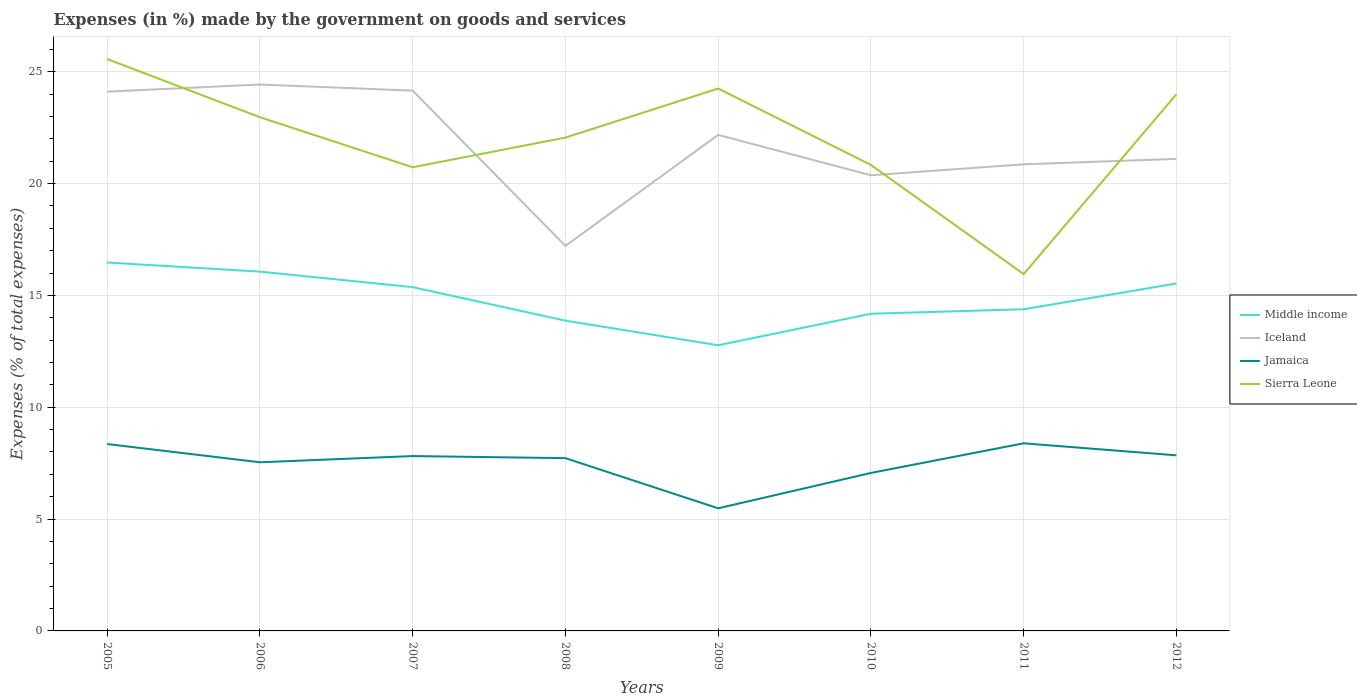How many different coloured lines are there?
Offer a very short reply. 4. Across all years, what is the maximum percentage of expenses made by the government on goods and services in Sierra Leone?
Keep it short and to the point. 15.95. In which year was the percentage of expenses made by the government on goods and services in Sierra Leone maximum?
Provide a succinct answer. 2011. What is the total percentage of expenses made by the government on goods and services in Jamaica in the graph?
Provide a succinct answer. -0.18. What is the difference between the highest and the second highest percentage of expenses made by the government on goods and services in Middle income?
Keep it short and to the point. 3.7. Is the percentage of expenses made by the government on goods and services in Jamaica strictly greater than the percentage of expenses made by the government on goods and services in Sierra Leone over the years?
Your answer should be compact. Yes. Are the values on the major ticks of Y-axis written in scientific E-notation?
Offer a terse response. No. Does the graph contain any zero values?
Offer a very short reply. No. Does the graph contain grids?
Provide a succinct answer. Yes. Where does the legend appear in the graph?
Offer a very short reply. Center right. How are the legend labels stacked?
Your response must be concise. Vertical. What is the title of the graph?
Your response must be concise. Expenses (in %) made by the government on goods and services. What is the label or title of the X-axis?
Provide a short and direct response. Years. What is the label or title of the Y-axis?
Give a very brief answer. Expenses (% of total expenses). What is the Expenses (% of total expenses) of Middle income in 2005?
Offer a terse response. 16.47. What is the Expenses (% of total expenses) in Iceland in 2005?
Offer a very short reply. 24.11. What is the Expenses (% of total expenses) of Jamaica in 2005?
Provide a succinct answer. 8.36. What is the Expenses (% of total expenses) of Sierra Leone in 2005?
Keep it short and to the point. 25.57. What is the Expenses (% of total expenses) in Middle income in 2006?
Your response must be concise. 16.07. What is the Expenses (% of total expenses) in Iceland in 2006?
Offer a terse response. 24.43. What is the Expenses (% of total expenses) in Jamaica in 2006?
Provide a short and direct response. 7.54. What is the Expenses (% of total expenses) in Sierra Leone in 2006?
Offer a very short reply. 22.97. What is the Expenses (% of total expenses) in Middle income in 2007?
Your answer should be compact. 15.37. What is the Expenses (% of total expenses) in Iceland in 2007?
Offer a terse response. 24.16. What is the Expenses (% of total expenses) in Jamaica in 2007?
Make the answer very short. 7.82. What is the Expenses (% of total expenses) in Sierra Leone in 2007?
Keep it short and to the point. 20.73. What is the Expenses (% of total expenses) of Middle income in 2008?
Give a very brief answer. 13.87. What is the Expenses (% of total expenses) of Iceland in 2008?
Your answer should be very brief. 17.22. What is the Expenses (% of total expenses) of Jamaica in 2008?
Your response must be concise. 7.72. What is the Expenses (% of total expenses) in Sierra Leone in 2008?
Keep it short and to the point. 22.06. What is the Expenses (% of total expenses) in Middle income in 2009?
Provide a succinct answer. 12.77. What is the Expenses (% of total expenses) of Iceland in 2009?
Make the answer very short. 22.18. What is the Expenses (% of total expenses) in Jamaica in 2009?
Provide a short and direct response. 5.48. What is the Expenses (% of total expenses) in Sierra Leone in 2009?
Provide a short and direct response. 24.25. What is the Expenses (% of total expenses) of Middle income in 2010?
Offer a very short reply. 14.18. What is the Expenses (% of total expenses) of Iceland in 2010?
Keep it short and to the point. 20.37. What is the Expenses (% of total expenses) in Jamaica in 2010?
Offer a terse response. 7.06. What is the Expenses (% of total expenses) in Sierra Leone in 2010?
Provide a succinct answer. 20.84. What is the Expenses (% of total expenses) in Middle income in 2011?
Your answer should be very brief. 14.38. What is the Expenses (% of total expenses) of Iceland in 2011?
Your answer should be compact. 20.86. What is the Expenses (% of total expenses) of Jamaica in 2011?
Provide a short and direct response. 8.39. What is the Expenses (% of total expenses) in Sierra Leone in 2011?
Your response must be concise. 15.95. What is the Expenses (% of total expenses) of Middle income in 2012?
Your answer should be compact. 15.53. What is the Expenses (% of total expenses) of Iceland in 2012?
Make the answer very short. 21.11. What is the Expenses (% of total expenses) in Jamaica in 2012?
Provide a succinct answer. 7.85. What is the Expenses (% of total expenses) of Sierra Leone in 2012?
Give a very brief answer. 24. Across all years, what is the maximum Expenses (% of total expenses) in Middle income?
Your answer should be very brief. 16.47. Across all years, what is the maximum Expenses (% of total expenses) in Iceland?
Offer a very short reply. 24.43. Across all years, what is the maximum Expenses (% of total expenses) in Jamaica?
Ensure brevity in your answer.  8.39. Across all years, what is the maximum Expenses (% of total expenses) in Sierra Leone?
Ensure brevity in your answer.  25.57. Across all years, what is the minimum Expenses (% of total expenses) in Middle income?
Your response must be concise. 12.77. Across all years, what is the minimum Expenses (% of total expenses) of Iceland?
Offer a very short reply. 17.22. Across all years, what is the minimum Expenses (% of total expenses) in Jamaica?
Ensure brevity in your answer.  5.48. Across all years, what is the minimum Expenses (% of total expenses) in Sierra Leone?
Your answer should be compact. 15.95. What is the total Expenses (% of total expenses) in Middle income in the graph?
Keep it short and to the point. 118.65. What is the total Expenses (% of total expenses) in Iceland in the graph?
Your answer should be very brief. 174.44. What is the total Expenses (% of total expenses) in Jamaica in the graph?
Keep it short and to the point. 60.22. What is the total Expenses (% of total expenses) in Sierra Leone in the graph?
Make the answer very short. 176.37. What is the difference between the Expenses (% of total expenses) of Middle income in 2005 and that in 2006?
Offer a very short reply. 0.41. What is the difference between the Expenses (% of total expenses) in Iceland in 2005 and that in 2006?
Give a very brief answer. -0.32. What is the difference between the Expenses (% of total expenses) in Jamaica in 2005 and that in 2006?
Provide a succinct answer. 0.82. What is the difference between the Expenses (% of total expenses) of Sierra Leone in 2005 and that in 2006?
Your answer should be very brief. 2.6. What is the difference between the Expenses (% of total expenses) in Middle income in 2005 and that in 2007?
Provide a succinct answer. 1.1. What is the difference between the Expenses (% of total expenses) in Iceland in 2005 and that in 2007?
Your answer should be compact. -0.04. What is the difference between the Expenses (% of total expenses) of Jamaica in 2005 and that in 2007?
Make the answer very short. 0.54. What is the difference between the Expenses (% of total expenses) in Sierra Leone in 2005 and that in 2007?
Give a very brief answer. 4.84. What is the difference between the Expenses (% of total expenses) in Middle income in 2005 and that in 2008?
Make the answer very short. 2.6. What is the difference between the Expenses (% of total expenses) in Iceland in 2005 and that in 2008?
Your answer should be compact. 6.9. What is the difference between the Expenses (% of total expenses) in Jamaica in 2005 and that in 2008?
Make the answer very short. 0.63. What is the difference between the Expenses (% of total expenses) of Sierra Leone in 2005 and that in 2008?
Ensure brevity in your answer.  3.51. What is the difference between the Expenses (% of total expenses) of Middle income in 2005 and that in 2009?
Provide a short and direct response. 3.7. What is the difference between the Expenses (% of total expenses) in Iceland in 2005 and that in 2009?
Your answer should be compact. 1.93. What is the difference between the Expenses (% of total expenses) of Jamaica in 2005 and that in 2009?
Offer a very short reply. 2.87. What is the difference between the Expenses (% of total expenses) of Sierra Leone in 2005 and that in 2009?
Offer a terse response. 1.32. What is the difference between the Expenses (% of total expenses) in Middle income in 2005 and that in 2010?
Offer a very short reply. 2.29. What is the difference between the Expenses (% of total expenses) in Iceland in 2005 and that in 2010?
Provide a short and direct response. 3.74. What is the difference between the Expenses (% of total expenses) of Jamaica in 2005 and that in 2010?
Make the answer very short. 1.29. What is the difference between the Expenses (% of total expenses) of Sierra Leone in 2005 and that in 2010?
Keep it short and to the point. 4.73. What is the difference between the Expenses (% of total expenses) of Middle income in 2005 and that in 2011?
Give a very brief answer. 2.09. What is the difference between the Expenses (% of total expenses) in Iceland in 2005 and that in 2011?
Provide a succinct answer. 3.25. What is the difference between the Expenses (% of total expenses) of Jamaica in 2005 and that in 2011?
Provide a succinct answer. -0.03. What is the difference between the Expenses (% of total expenses) of Sierra Leone in 2005 and that in 2011?
Your response must be concise. 9.62. What is the difference between the Expenses (% of total expenses) in Middle income in 2005 and that in 2012?
Give a very brief answer. 0.94. What is the difference between the Expenses (% of total expenses) of Iceland in 2005 and that in 2012?
Ensure brevity in your answer.  3.01. What is the difference between the Expenses (% of total expenses) of Jamaica in 2005 and that in 2012?
Offer a very short reply. 0.51. What is the difference between the Expenses (% of total expenses) in Sierra Leone in 2005 and that in 2012?
Offer a terse response. 1.57. What is the difference between the Expenses (% of total expenses) of Middle income in 2006 and that in 2007?
Your answer should be compact. 0.69. What is the difference between the Expenses (% of total expenses) of Iceland in 2006 and that in 2007?
Make the answer very short. 0.27. What is the difference between the Expenses (% of total expenses) of Jamaica in 2006 and that in 2007?
Your answer should be compact. -0.28. What is the difference between the Expenses (% of total expenses) in Sierra Leone in 2006 and that in 2007?
Provide a short and direct response. 2.24. What is the difference between the Expenses (% of total expenses) of Middle income in 2006 and that in 2008?
Give a very brief answer. 2.19. What is the difference between the Expenses (% of total expenses) of Iceland in 2006 and that in 2008?
Offer a very short reply. 7.22. What is the difference between the Expenses (% of total expenses) of Jamaica in 2006 and that in 2008?
Make the answer very short. -0.18. What is the difference between the Expenses (% of total expenses) in Sierra Leone in 2006 and that in 2008?
Your answer should be very brief. 0.91. What is the difference between the Expenses (% of total expenses) in Middle income in 2006 and that in 2009?
Ensure brevity in your answer.  3.29. What is the difference between the Expenses (% of total expenses) of Iceland in 2006 and that in 2009?
Offer a terse response. 2.25. What is the difference between the Expenses (% of total expenses) in Jamaica in 2006 and that in 2009?
Keep it short and to the point. 2.06. What is the difference between the Expenses (% of total expenses) in Sierra Leone in 2006 and that in 2009?
Ensure brevity in your answer.  -1.28. What is the difference between the Expenses (% of total expenses) in Middle income in 2006 and that in 2010?
Your answer should be compact. 1.88. What is the difference between the Expenses (% of total expenses) of Iceland in 2006 and that in 2010?
Ensure brevity in your answer.  4.06. What is the difference between the Expenses (% of total expenses) of Jamaica in 2006 and that in 2010?
Give a very brief answer. 0.48. What is the difference between the Expenses (% of total expenses) of Sierra Leone in 2006 and that in 2010?
Ensure brevity in your answer.  2.13. What is the difference between the Expenses (% of total expenses) of Middle income in 2006 and that in 2011?
Ensure brevity in your answer.  1.68. What is the difference between the Expenses (% of total expenses) of Iceland in 2006 and that in 2011?
Your answer should be very brief. 3.57. What is the difference between the Expenses (% of total expenses) in Jamaica in 2006 and that in 2011?
Offer a very short reply. -0.85. What is the difference between the Expenses (% of total expenses) of Sierra Leone in 2006 and that in 2011?
Give a very brief answer. 7.01. What is the difference between the Expenses (% of total expenses) in Middle income in 2006 and that in 2012?
Make the answer very short. 0.53. What is the difference between the Expenses (% of total expenses) of Iceland in 2006 and that in 2012?
Offer a terse response. 3.33. What is the difference between the Expenses (% of total expenses) of Jamaica in 2006 and that in 2012?
Give a very brief answer. -0.31. What is the difference between the Expenses (% of total expenses) of Sierra Leone in 2006 and that in 2012?
Your answer should be compact. -1.03. What is the difference between the Expenses (% of total expenses) in Middle income in 2007 and that in 2008?
Give a very brief answer. 1.5. What is the difference between the Expenses (% of total expenses) of Iceland in 2007 and that in 2008?
Ensure brevity in your answer.  6.94. What is the difference between the Expenses (% of total expenses) in Jamaica in 2007 and that in 2008?
Offer a very short reply. 0.09. What is the difference between the Expenses (% of total expenses) in Sierra Leone in 2007 and that in 2008?
Your answer should be very brief. -1.33. What is the difference between the Expenses (% of total expenses) of Middle income in 2007 and that in 2009?
Make the answer very short. 2.6. What is the difference between the Expenses (% of total expenses) in Iceland in 2007 and that in 2009?
Offer a terse response. 1.98. What is the difference between the Expenses (% of total expenses) in Jamaica in 2007 and that in 2009?
Provide a succinct answer. 2.34. What is the difference between the Expenses (% of total expenses) in Sierra Leone in 2007 and that in 2009?
Your answer should be compact. -3.52. What is the difference between the Expenses (% of total expenses) in Middle income in 2007 and that in 2010?
Your answer should be compact. 1.19. What is the difference between the Expenses (% of total expenses) of Iceland in 2007 and that in 2010?
Your response must be concise. 3.78. What is the difference between the Expenses (% of total expenses) of Jamaica in 2007 and that in 2010?
Offer a terse response. 0.75. What is the difference between the Expenses (% of total expenses) of Sierra Leone in 2007 and that in 2010?
Provide a succinct answer. -0.1. What is the difference between the Expenses (% of total expenses) in Middle income in 2007 and that in 2011?
Ensure brevity in your answer.  0.99. What is the difference between the Expenses (% of total expenses) of Iceland in 2007 and that in 2011?
Provide a short and direct response. 3.29. What is the difference between the Expenses (% of total expenses) in Jamaica in 2007 and that in 2011?
Ensure brevity in your answer.  -0.57. What is the difference between the Expenses (% of total expenses) in Sierra Leone in 2007 and that in 2011?
Provide a short and direct response. 4.78. What is the difference between the Expenses (% of total expenses) in Middle income in 2007 and that in 2012?
Provide a short and direct response. -0.16. What is the difference between the Expenses (% of total expenses) of Iceland in 2007 and that in 2012?
Offer a terse response. 3.05. What is the difference between the Expenses (% of total expenses) in Jamaica in 2007 and that in 2012?
Make the answer very short. -0.03. What is the difference between the Expenses (% of total expenses) in Sierra Leone in 2007 and that in 2012?
Keep it short and to the point. -3.27. What is the difference between the Expenses (% of total expenses) of Middle income in 2008 and that in 2009?
Your answer should be very brief. 1.1. What is the difference between the Expenses (% of total expenses) of Iceland in 2008 and that in 2009?
Keep it short and to the point. -4.96. What is the difference between the Expenses (% of total expenses) in Jamaica in 2008 and that in 2009?
Ensure brevity in your answer.  2.24. What is the difference between the Expenses (% of total expenses) of Sierra Leone in 2008 and that in 2009?
Make the answer very short. -2.19. What is the difference between the Expenses (% of total expenses) of Middle income in 2008 and that in 2010?
Make the answer very short. -0.31. What is the difference between the Expenses (% of total expenses) of Iceland in 2008 and that in 2010?
Provide a short and direct response. -3.16. What is the difference between the Expenses (% of total expenses) of Jamaica in 2008 and that in 2010?
Your answer should be compact. 0.66. What is the difference between the Expenses (% of total expenses) of Sierra Leone in 2008 and that in 2010?
Offer a very short reply. 1.22. What is the difference between the Expenses (% of total expenses) of Middle income in 2008 and that in 2011?
Your response must be concise. -0.51. What is the difference between the Expenses (% of total expenses) of Iceland in 2008 and that in 2011?
Ensure brevity in your answer.  -3.65. What is the difference between the Expenses (% of total expenses) of Jamaica in 2008 and that in 2011?
Keep it short and to the point. -0.66. What is the difference between the Expenses (% of total expenses) of Sierra Leone in 2008 and that in 2011?
Provide a short and direct response. 6.1. What is the difference between the Expenses (% of total expenses) in Middle income in 2008 and that in 2012?
Your answer should be compact. -1.66. What is the difference between the Expenses (% of total expenses) of Iceland in 2008 and that in 2012?
Your answer should be compact. -3.89. What is the difference between the Expenses (% of total expenses) of Jamaica in 2008 and that in 2012?
Your answer should be compact. -0.13. What is the difference between the Expenses (% of total expenses) in Sierra Leone in 2008 and that in 2012?
Ensure brevity in your answer.  -1.94. What is the difference between the Expenses (% of total expenses) of Middle income in 2009 and that in 2010?
Keep it short and to the point. -1.41. What is the difference between the Expenses (% of total expenses) of Iceland in 2009 and that in 2010?
Provide a short and direct response. 1.8. What is the difference between the Expenses (% of total expenses) of Jamaica in 2009 and that in 2010?
Your answer should be very brief. -1.58. What is the difference between the Expenses (% of total expenses) of Sierra Leone in 2009 and that in 2010?
Keep it short and to the point. 3.42. What is the difference between the Expenses (% of total expenses) in Middle income in 2009 and that in 2011?
Your answer should be very brief. -1.61. What is the difference between the Expenses (% of total expenses) in Iceland in 2009 and that in 2011?
Ensure brevity in your answer.  1.32. What is the difference between the Expenses (% of total expenses) of Jamaica in 2009 and that in 2011?
Make the answer very short. -2.91. What is the difference between the Expenses (% of total expenses) in Sierra Leone in 2009 and that in 2011?
Offer a very short reply. 8.3. What is the difference between the Expenses (% of total expenses) in Middle income in 2009 and that in 2012?
Give a very brief answer. -2.76. What is the difference between the Expenses (% of total expenses) of Iceland in 2009 and that in 2012?
Make the answer very short. 1.07. What is the difference between the Expenses (% of total expenses) of Jamaica in 2009 and that in 2012?
Provide a short and direct response. -2.37. What is the difference between the Expenses (% of total expenses) in Sierra Leone in 2009 and that in 2012?
Offer a terse response. 0.25. What is the difference between the Expenses (% of total expenses) of Middle income in 2010 and that in 2011?
Your answer should be compact. -0.2. What is the difference between the Expenses (% of total expenses) in Iceland in 2010 and that in 2011?
Make the answer very short. -0.49. What is the difference between the Expenses (% of total expenses) of Jamaica in 2010 and that in 2011?
Offer a terse response. -1.32. What is the difference between the Expenses (% of total expenses) of Sierra Leone in 2010 and that in 2011?
Ensure brevity in your answer.  4.88. What is the difference between the Expenses (% of total expenses) of Middle income in 2010 and that in 2012?
Your answer should be very brief. -1.35. What is the difference between the Expenses (% of total expenses) of Iceland in 2010 and that in 2012?
Give a very brief answer. -0.73. What is the difference between the Expenses (% of total expenses) of Jamaica in 2010 and that in 2012?
Your answer should be compact. -0.79. What is the difference between the Expenses (% of total expenses) of Sierra Leone in 2010 and that in 2012?
Make the answer very short. -3.16. What is the difference between the Expenses (% of total expenses) of Middle income in 2011 and that in 2012?
Offer a terse response. -1.15. What is the difference between the Expenses (% of total expenses) in Iceland in 2011 and that in 2012?
Your response must be concise. -0.24. What is the difference between the Expenses (% of total expenses) of Jamaica in 2011 and that in 2012?
Your response must be concise. 0.54. What is the difference between the Expenses (% of total expenses) of Sierra Leone in 2011 and that in 2012?
Ensure brevity in your answer.  -8.04. What is the difference between the Expenses (% of total expenses) in Middle income in 2005 and the Expenses (% of total expenses) in Iceland in 2006?
Ensure brevity in your answer.  -7.96. What is the difference between the Expenses (% of total expenses) in Middle income in 2005 and the Expenses (% of total expenses) in Jamaica in 2006?
Ensure brevity in your answer.  8.93. What is the difference between the Expenses (% of total expenses) in Middle income in 2005 and the Expenses (% of total expenses) in Sierra Leone in 2006?
Make the answer very short. -6.5. What is the difference between the Expenses (% of total expenses) in Iceland in 2005 and the Expenses (% of total expenses) in Jamaica in 2006?
Offer a terse response. 16.57. What is the difference between the Expenses (% of total expenses) in Iceland in 2005 and the Expenses (% of total expenses) in Sierra Leone in 2006?
Offer a terse response. 1.14. What is the difference between the Expenses (% of total expenses) in Jamaica in 2005 and the Expenses (% of total expenses) in Sierra Leone in 2006?
Your answer should be compact. -14.61. What is the difference between the Expenses (% of total expenses) of Middle income in 2005 and the Expenses (% of total expenses) of Iceland in 2007?
Keep it short and to the point. -7.68. What is the difference between the Expenses (% of total expenses) of Middle income in 2005 and the Expenses (% of total expenses) of Jamaica in 2007?
Your answer should be very brief. 8.65. What is the difference between the Expenses (% of total expenses) of Middle income in 2005 and the Expenses (% of total expenses) of Sierra Leone in 2007?
Keep it short and to the point. -4.26. What is the difference between the Expenses (% of total expenses) in Iceland in 2005 and the Expenses (% of total expenses) in Jamaica in 2007?
Your response must be concise. 16.29. What is the difference between the Expenses (% of total expenses) of Iceland in 2005 and the Expenses (% of total expenses) of Sierra Leone in 2007?
Your answer should be very brief. 3.38. What is the difference between the Expenses (% of total expenses) in Jamaica in 2005 and the Expenses (% of total expenses) in Sierra Leone in 2007?
Offer a very short reply. -12.38. What is the difference between the Expenses (% of total expenses) of Middle income in 2005 and the Expenses (% of total expenses) of Iceland in 2008?
Ensure brevity in your answer.  -0.74. What is the difference between the Expenses (% of total expenses) in Middle income in 2005 and the Expenses (% of total expenses) in Jamaica in 2008?
Your response must be concise. 8.75. What is the difference between the Expenses (% of total expenses) of Middle income in 2005 and the Expenses (% of total expenses) of Sierra Leone in 2008?
Provide a short and direct response. -5.58. What is the difference between the Expenses (% of total expenses) in Iceland in 2005 and the Expenses (% of total expenses) in Jamaica in 2008?
Offer a terse response. 16.39. What is the difference between the Expenses (% of total expenses) in Iceland in 2005 and the Expenses (% of total expenses) in Sierra Leone in 2008?
Provide a succinct answer. 2.05. What is the difference between the Expenses (% of total expenses) in Jamaica in 2005 and the Expenses (% of total expenses) in Sierra Leone in 2008?
Offer a terse response. -13.7. What is the difference between the Expenses (% of total expenses) in Middle income in 2005 and the Expenses (% of total expenses) in Iceland in 2009?
Offer a very short reply. -5.71. What is the difference between the Expenses (% of total expenses) in Middle income in 2005 and the Expenses (% of total expenses) in Jamaica in 2009?
Your answer should be very brief. 10.99. What is the difference between the Expenses (% of total expenses) in Middle income in 2005 and the Expenses (% of total expenses) in Sierra Leone in 2009?
Your answer should be compact. -7.78. What is the difference between the Expenses (% of total expenses) of Iceland in 2005 and the Expenses (% of total expenses) of Jamaica in 2009?
Offer a very short reply. 18.63. What is the difference between the Expenses (% of total expenses) of Iceland in 2005 and the Expenses (% of total expenses) of Sierra Leone in 2009?
Your answer should be compact. -0.14. What is the difference between the Expenses (% of total expenses) of Jamaica in 2005 and the Expenses (% of total expenses) of Sierra Leone in 2009?
Give a very brief answer. -15.9. What is the difference between the Expenses (% of total expenses) of Middle income in 2005 and the Expenses (% of total expenses) of Iceland in 2010?
Keep it short and to the point. -3.9. What is the difference between the Expenses (% of total expenses) in Middle income in 2005 and the Expenses (% of total expenses) in Jamaica in 2010?
Ensure brevity in your answer.  9.41. What is the difference between the Expenses (% of total expenses) of Middle income in 2005 and the Expenses (% of total expenses) of Sierra Leone in 2010?
Make the answer very short. -4.36. What is the difference between the Expenses (% of total expenses) of Iceland in 2005 and the Expenses (% of total expenses) of Jamaica in 2010?
Offer a very short reply. 17.05. What is the difference between the Expenses (% of total expenses) of Iceland in 2005 and the Expenses (% of total expenses) of Sierra Leone in 2010?
Your response must be concise. 3.28. What is the difference between the Expenses (% of total expenses) in Jamaica in 2005 and the Expenses (% of total expenses) in Sierra Leone in 2010?
Offer a terse response. -12.48. What is the difference between the Expenses (% of total expenses) of Middle income in 2005 and the Expenses (% of total expenses) of Iceland in 2011?
Ensure brevity in your answer.  -4.39. What is the difference between the Expenses (% of total expenses) in Middle income in 2005 and the Expenses (% of total expenses) in Jamaica in 2011?
Provide a succinct answer. 8.08. What is the difference between the Expenses (% of total expenses) of Middle income in 2005 and the Expenses (% of total expenses) of Sierra Leone in 2011?
Keep it short and to the point. 0.52. What is the difference between the Expenses (% of total expenses) in Iceland in 2005 and the Expenses (% of total expenses) in Jamaica in 2011?
Offer a very short reply. 15.72. What is the difference between the Expenses (% of total expenses) of Iceland in 2005 and the Expenses (% of total expenses) of Sierra Leone in 2011?
Provide a succinct answer. 8.16. What is the difference between the Expenses (% of total expenses) in Jamaica in 2005 and the Expenses (% of total expenses) in Sierra Leone in 2011?
Offer a very short reply. -7.6. What is the difference between the Expenses (% of total expenses) in Middle income in 2005 and the Expenses (% of total expenses) in Iceland in 2012?
Offer a terse response. -4.63. What is the difference between the Expenses (% of total expenses) of Middle income in 2005 and the Expenses (% of total expenses) of Jamaica in 2012?
Offer a very short reply. 8.62. What is the difference between the Expenses (% of total expenses) of Middle income in 2005 and the Expenses (% of total expenses) of Sierra Leone in 2012?
Give a very brief answer. -7.52. What is the difference between the Expenses (% of total expenses) in Iceland in 2005 and the Expenses (% of total expenses) in Jamaica in 2012?
Ensure brevity in your answer.  16.26. What is the difference between the Expenses (% of total expenses) of Iceland in 2005 and the Expenses (% of total expenses) of Sierra Leone in 2012?
Ensure brevity in your answer.  0.12. What is the difference between the Expenses (% of total expenses) in Jamaica in 2005 and the Expenses (% of total expenses) in Sierra Leone in 2012?
Provide a succinct answer. -15.64. What is the difference between the Expenses (% of total expenses) in Middle income in 2006 and the Expenses (% of total expenses) in Iceland in 2007?
Provide a short and direct response. -8.09. What is the difference between the Expenses (% of total expenses) of Middle income in 2006 and the Expenses (% of total expenses) of Jamaica in 2007?
Provide a short and direct response. 8.25. What is the difference between the Expenses (% of total expenses) of Middle income in 2006 and the Expenses (% of total expenses) of Sierra Leone in 2007?
Provide a succinct answer. -4.67. What is the difference between the Expenses (% of total expenses) in Iceland in 2006 and the Expenses (% of total expenses) in Jamaica in 2007?
Keep it short and to the point. 16.61. What is the difference between the Expenses (% of total expenses) of Iceland in 2006 and the Expenses (% of total expenses) of Sierra Leone in 2007?
Ensure brevity in your answer.  3.7. What is the difference between the Expenses (% of total expenses) of Jamaica in 2006 and the Expenses (% of total expenses) of Sierra Leone in 2007?
Keep it short and to the point. -13.19. What is the difference between the Expenses (% of total expenses) in Middle income in 2006 and the Expenses (% of total expenses) in Iceland in 2008?
Offer a terse response. -1.15. What is the difference between the Expenses (% of total expenses) of Middle income in 2006 and the Expenses (% of total expenses) of Jamaica in 2008?
Your response must be concise. 8.34. What is the difference between the Expenses (% of total expenses) in Middle income in 2006 and the Expenses (% of total expenses) in Sierra Leone in 2008?
Make the answer very short. -5.99. What is the difference between the Expenses (% of total expenses) in Iceland in 2006 and the Expenses (% of total expenses) in Jamaica in 2008?
Ensure brevity in your answer.  16.71. What is the difference between the Expenses (% of total expenses) of Iceland in 2006 and the Expenses (% of total expenses) of Sierra Leone in 2008?
Your response must be concise. 2.37. What is the difference between the Expenses (% of total expenses) of Jamaica in 2006 and the Expenses (% of total expenses) of Sierra Leone in 2008?
Your answer should be very brief. -14.52. What is the difference between the Expenses (% of total expenses) in Middle income in 2006 and the Expenses (% of total expenses) in Iceland in 2009?
Make the answer very short. -6.11. What is the difference between the Expenses (% of total expenses) of Middle income in 2006 and the Expenses (% of total expenses) of Jamaica in 2009?
Your answer should be compact. 10.58. What is the difference between the Expenses (% of total expenses) of Middle income in 2006 and the Expenses (% of total expenses) of Sierra Leone in 2009?
Your answer should be compact. -8.19. What is the difference between the Expenses (% of total expenses) of Iceland in 2006 and the Expenses (% of total expenses) of Jamaica in 2009?
Offer a terse response. 18.95. What is the difference between the Expenses (% of total expenses) in Iceland in 2006 and the Expenses (% of total expenses) in Sierra Leone in 2009?
Your response must be concise. 0.18. What is the difference between the Expenses (% of total expenses) of Jamaica in 2006 and the Expenses (% of total expenses) of Sierra Leone in 2009?
Offer a terse response. -16.71. What is the difference between the Expenses (% of total expenses) of Middle income in 2006 and the Expenses (% of total expenses) of Iceland in 2010?
Make the answer very short. -4.31. What is the difference between the Expenses (% of total expenses) in Middle income in 2006 and the Expenses (% of total expenses) in Jamaica in 2010?
Your response must be concise. 9. What is the difference between the Expenses (% of total expenses) in Middle income in 2006 and the Expenses (% of total expenses) in Sierra Leone in 2010?
Your response must be concise. -4.77. What is the difference between the Expenses (% of total expenses) of Iceland in 2006 and the Expenses (% of total expenses) of Jamaica in 2010?
Offer a terse response. 17.37. What is the difference between the Expenses (% of total expenses) of Iceland in 2006 and the Expenses (% of total expenses) of Sierra Leone in 2010?
Ensure brevity in your answer.  3.6. What is the difference between the Expenses (% of total expenses) in Jamaica in 2006 and the Expenses (% of total expenses) in Sierra Leone in 2010?
Give a very brief answer. -13.3. What is the difference between the Expenses (% of total expenses) of Middle income in 2006 and the Expenses (% of total expenses) of Iceland in 2011?
Offer a terse response. -4.8. What is the difference between the Expenses (% of total expenses) of Middle income in 2006 and the Expenses (% of total expenses) of Jamaica in 2011?
Provide a short and direct response. 7.68. What is the difference between the Expenses (% of total expenses) in Middle income in 2006 and the Expenses (% of total expenses) in Sierra Leone in 2011?
Your response must be concise. 0.11. What is the difference between the Expenses (% of total expenses) in Iceland in 2006 and the Expenses (% of total expenses) in Jamaica in 2011?
Ensure brevity in your answer.  16.04. What is the difference between the Expenses (% of total expenses) of Iceland in 2006 and the Expenses (% of total expenses) of Sierra Leone in 2011?
Provide a short and direct response. 8.48. What is the difference between the Expenses (% of total expenses) of Jamaica in 2006 and the Expenses (% of total expenses) of Sierra Leone in 2011?
Your answer should be very brief. -8.41. What is the difference between the Expenses (% of total expenses) of Middle income in 2006 and the Expenses (% of total expenses) of Iceland in 2012?
Make the answer very short. -5.04. What is the difference between the Expenses (% of total expenses) in Middle income in 2006 and the Expenses (% of total expenses) in Jamaica in 2012?
Provide a short and direct response. 8.21. What is the difference between the Expenses (% of total expenses) in Middle income in 2006 and the Expenses (% of total expenses) in Sierra Leone in 2012?
Provide a short and direct response. -7.93. What is the difference between the Expenses (% of total expenses) of Iceland in 2006 and the Expenses (% of total expenses) of Jamaica in 2012?
Your response must be concise. 16.58. What is the difference between the Expenses (% of total expenses) in Iceland in 2006 and the Expenses (% of total expenses) in Sierra Leone in 2012?
Provide a short and direct response. 0.43. What is the difference between the Expenses (% of total expenses) in Jamaica in 2006 and the Expenses (% of total expenses) in Sierra Leone in 2012?
Your answer should be compact. -16.46. What is the difference between the Expenses (% of total expenses) of Middle income in 2007 and the Expenses (% of total expenses) of Iceland in 2008?
Make the answer very short. -1.84. What is the difference between the Expenses (% of total expenses) of Middle income in 2007 and the Expenses (% of total expenses) of Jamaica in 2008?
Your answer should be compact. 7.65. What is the difference between the Expenses (% of total expenses) in Middle income in 2007 and the Expenses (% of total expenses) in Sierra Leone in 2008?
Your response must be concise. -6.69. What is the difference between the Expenses (% of total expenses) of Iceland in 2007 and the Expenses (% of total expenses) of Jamaica in 2008?
Offer a very short reply. 16.43. What is the difference between the Expenses (% of total expenses) in Iceland in 2007 and the Expenses (% of total expenses) in Sierra Leone in 2008?
Provide a short and direct response. 2.1. What is the difference between the Expenses (% of total expenses) in Jamaica in 2007 and the Expenses (% of total expenses) in Sierra Leone in 2008?
Give a very brief answer. -14.24. What is the difference between the Expenses (% of total expenses) in Middle income in 2007 and the Expenses (% of total expenses) in Iceland in 2009?
Offer a very short reply. -6.81. What is the difference between the Expenses (% of total expenses) of Middle income in 2007 and the Expenses (% of total expenses) of Jamaica in 2009?
Offer a very short reply. 9.89. What is the difference between the Expenses (% of total expenses) in Middle income in 2007 and the Expenses (% of total expenses) in Sierra Leone in 2009?
Offer a very short reply. -8.88. What is the difference between the Expenses (% of total expenses) of Iceland in 2007 and the Expenses (% of total expenses) of Jamaica in 2009?
Provide a short and direct response. 18.67. What is the difference between the Expenses (% of total expenses) of Iceland in 2007 and the Expenses (% of total expenses) of Sierra Leone in 2009?
Your answer should be compact. -0.09. What is the difference between the Expenses (% of total expenses) in Jamaica in 2007 and the Expenses (% of total expenses) in Sierra Leone in 2009?
Offer a very short reply. -16.43. What is the difference between the Expenses (% of total expenses) of Middle income in 2007 and the Expenses (% of total expenses) of Iceland in 2010?
Offer a terse response. -5. What is the difference between the Expenses (% of total expenses) of Middle income in 2007 and the Expenses (% of total expenses) of Jamaica in 2010?
Your answer should be very brief. 8.31. What is the difference between the Expenses (% of total expenses) in Middle income in 2007 and the Expenses (% of total expenses) in Sierra Leone in 2010?
Provide a short and direct response. -5.46. What is the difference between the Expenses (% of total expenses) of Iceland in 2007 and the Expenses (% of total expenses) of Jamaica in 2010?
Provide a succinct answer. 17.09. What is the difference between the Expenses (% of total expenses) in Iceland in 2007 and the Expenses (% of total expenses) in Sierra Leone in 2010?
Your response must be concise. 3.32. What is the difference between the Expenses (% of total expenses) of Jamaica in 2007 and the Expenses (% of total expenses) of Sierra Leone in 2010?
Make the answer very short. -13.02. What is the difference between the Expenses (% of total expenses) in Middle income in 2007 and the Expenses (% of total expenses) in Iceland in 2011?
Offer a terse response. -5.49. What is the difference between the Expenses (% of total expenses) of Middle income in 2007 and the Expenses (% of total expenses) of Jamaica in 2011?
Ensure brevity in your answer.  6.98. What is the difference between the Expenses (% of total expenses) of Middle income in 2007 and the Expenses (% of total expenses) of Sierra Leone in 2011?
Ensure brevity in your answer.  -0.58. What is the difference between the Expenses (% of total expenses) of Iceland in 2007 and the Expenses (% of total expenses) of Jamaica in 2011?
Your response must be concise. 15.77. What is the difference between the Expenses (% of total expenses) of Iceland in 2007 and the Expenses (% of total expenses) of Sierra Leone in 2011?
Offer a terse response. 8.2. What is the difference between the Expenses (% of total expenses) in Jamaica in 2007 and the Expenses (% of total expenses) in Sierra Leone in 2011?
Offer a terse response. -8.14. What is the difference between the Expenses (% of total expenses) in Middle income in 2007 and the Expenses (% of total expenses) in Iceland in 2012?
Your answer should be compact. -5.73. What is the difference between the Expenses (% of total expenses) in Middle income in 2007 and the Expenses (% of total expenses) in Jamaica in 2012?
Your answer should be very brief. 7.52. What is the difference between the Expenses (% of total expenses) in Middle income in 2007 and the Expenses (% of total expenses) in Sierra Leone in 2012?
Offer a very short reply. -8.63. What is the difference between the Expenses (% of total expenses) of Iceland in 2007 and the Expenses (% of total expenses) of Jamaica in 2012?
Your response must be concise. 16.31. What is the difference between the Expenses (% of total expenses) of Iceland in 2007 and the Expenses (% of total expenses) of Sierra Leone in 2012?
Keep it short and to the point. 0.16. What is the difference between the Expenses (% of total expenses) in Jamaica in 2007 and the Expenses (% of total expenses) in Sierra Leone in 2012?
Provide a succinct answer. -16.18. What is the difference between the Expenses (% of total expenses) in Middle income in 2008 and the Expenses (% of total expenses) in Iceland in 2009?
Offer a very short reply. -8.31. What is the difference between the Expenses (% of total expenses) of Middle income in 2008 and the Expenses (% of total expenses) of Jamaica in 2009?
Your response must be concise. 8.39. What is the difference between the Expenses (% of total expenses) of Middle income in 2008 and the Expenses (% of total expenses) of Sierra Leone in 2009?
Offer a terse response. -10.38. What is the difference between the Expenses (% of total expenses) of Iceland in 2008 and the Expenses (% of total expenses) of Jamaica in 2009?
Provide a succinct answer. 11.73. What is the difference between the Expenses (% of total expenses) of Iceland in 2008 and the Expenses (% of total expenses) of Sierra Leone in 2009?
Ensure brevity in your answer.  -7.04. What is the difference between the Expenses (% of total expenses) of Jamaica in 2008 and the Expenses (% of total expenses) of Sierra Leone in 2009?
Provide a succinct answer. -16.53. What is the difference between the Expenses (% of total expenses) of Middle income in 2008 and the Expenses (% of total expenses) of Iceland in 2010?
Give a very brief answer. -6.5. What is the difference between the Expenses (% of total expenses) in Middle income in 2008 and the Expenses (% of total expenses) in Jamaica in 2010?
Offer a very short reply. 6.81. What is the difference between the Expenses (% of total expenses) in Middle income in 2008 and the Expenses (% of total expenses) in Sierra Leone in 2010?
Make the answer very short. -6.96. What is the difference between the Expenses (% of total expenses) of Iceland in 2008 and the Expenses (% of total expenses) of Jamaica in 2010?
Provide a succinct answer. 10.15. What is the difference between the Expenses (% of total expenses) of Iceland in 2008 and the Expenses (% of total expenses) of Sierra Leone in 2010?
Offer a terse response. -3.62. What is the difference between the Expenses (% of total expenses) in Jamaica in 2008 and the Expenses (% of total expenses) in Sierra Leone in 2010?
Provide a succinct answer. -13.11. What is the difference between the Expenses (% of total expenses) of Middle income in 2008 and the Expenses (% of total expenses) of Iceland in 2011?
Give a very brief answer. -6.99. What is the difference between the Expenses (% of total expenses) of Middle income in 2008 and the Expenses (% of total expenses) of Jamaica in 2011?
Keep it short and to the point. 5.48. What is the difference between the Expenses (% of total expenses) of Middle income in 2008 and the Expenses (% of total expenses) of Sierra Leone in 2011?
Provide a short and direct response. -2.08. What is the difference between the Expenses (% of total expenses) of Iceland in 2008 and the Expenses (% of total expenses) of Jamaica in 2011?
Give a very brief answer. 8.83. What is the difference between the Expenses (% of total expenses) in Iceland in 2008 and the Expenses (% of total expenses) in Sierra Leone in 2011?
Keep it short and to the point. 1.26. What is the difference between the Expenses (% of total expenses) in Jamaica in 2008 and the Expenses (% of total expenses) in Sierra Leone in 2011?
Your answer should be compact. -8.23. What is the difference between the Expenses (% of total expenses) in Middle income in 2008 and the Expenses (% of total expenses) in Iceland in 2012?
Offer a very short reply. -7.23. What is the difference between the Expenses (% of total expenses) in Middle income in 2008 and the Expenses (% of total expenses) in Jamaica in 2012?
Ensure brevity in your answer.  6.02. What is the difference between the Expenses (% of total expenses) in Middle income in 2008 and the Expenses (% of total expenses) in Sierra Leone in 2012?
Keep it short and to the point. -10.12. What is the difference between the Expenses (% of total expenses) of Iceland in 2008 and the Expenses (% of total expenses) of Jamaica in 2012?
Keep it short and to the point. 9.37. What is the difference between the Expenses (% of total expenses) of Iceland in 2008 and the Expenses (% of total expenses) of Sierra Leone in 2012?
Provide a short and direct response. -6.78. What is the difference between the Expenses (% of total expenses) of Jamaica in 2008 and the Expenses (% of total expenses) of Sierra Leone in 2012?
Provide a succinct answer. -16.27. What is the difference between the Expenses (% of total expenses) of Middle income in 2009 and the Expenses (% of total expenses) of Iceland in 2010?
Keep it short and to the point. -7.6. What is the difference between the Expenses (% of total expenses) of Middle income in 2009 and the Expenses (% of total expenses) of Jamaica in 2010?
Give a very brief answer. 5.71. What is the difference between the Expenses (% of total expenses) in Middle income in 2009 and the Expenses (% of total expenses) in Sierra Leone in 2010?
Provide a short and direct response. -8.06. What is the difference between the Expenses (% of total expenses) of Iceland in 2009 and the Expenses (% of total expenses) of Jamaica in 2010?
Your response must be concise. 15.11. What is the difference between the Expenses (% of total expenses) of Iceland in 2009 and the Expenses (% of total expenses) of Sierra Leone in 2010?
Your answer should be very brief. 1.34. What is the difference between the Expenses (% of total expenses) of Jamaica in 2009 and the Expenses (% of total expenses) of Sierra Leone in 2010?
Offer a very short reply. -15.35. What is the difference between the Expenses (% of total expenses) of Middle income in 2009 and the Expenses (% of total expenses) of Iceland in 2011?
Offer a terse response. -8.09. What is the difference between the Expenses (% of total expenses) in Middle income in 2009 and the Expenses (% of total expenses) in Jamaica in 2011?
Your answer should be very brief. 4.38. What is the difference between the Expenses (% of total expenses) in Middle income in 2009 and the Expenses (% of total expenses) in Sierra Leone in 2011?
Keep it short and to the point. -3.18. What is the difference between the Expenses (% of total expenses) of Iceland in 2009 and the Expenses (% of total expenses) of Jamaica in 2011?
Give a very brief answer. 13.79. What is the difference between the Expenses (% of total expenses) in Iceland in 2009 and the Expenses (% of total expenses) in Sierra Leone in 2011?
Offer a terse response. 6.22. What is the difference between the Expenses (% of total expenses) of Jamaica in 2009 and the Expenses (% of total expenses) of Sierra Leone in 2011?
Your answer should be compact. -10.47. What is the difference between the Expenses (% of total expenses) in Middle income in 2009 and the Expenses (% of total expenses) in Iceland in 2012?
Make the answer very short. -8.33. What is the difference between the Expenses (% of total expenses) of Middle income in 2009 and the Expenses (% of total expenses) of Jamaica in 2012?
Offer a terse response. 4.92. What is the difference between the Expenses (% of total expenses) in Middle income in 2009 and the Expenses (% of total expenses) in Sierra Leone in 2012?
Provide a succinct answer. -11.22. What is the difference between the Expenses (% of total expenses) of Iceland in 2009 and the Expenses (% of total expenses) of Jamaica in 2012?
Ensure brevity in your answer.  14.33. What is the difference between the Expenses (% of total expenses) of Iceland in 2009 and the Expenses (% of total expenses) of Sierra Leone in 2012?
Keep it short and to the point. -1.82. What is the difference between the Expenses (% of total expenses) of Jamaica in 2009 and the Expenses (% of total expenses) of Sierra Leone in 2012?
Provide a short and direct response. -18.51. What is the difference between the Expenses (% of total expenses) of Middle income in 2010 and the Expenses (% of total expenses) of Iceland in 2011?
Provide a short and direct response. -6.68. What is the difference between the Expenses (% of total expenses) in Middle income in 2010 and the Expenses (% of total expenses) in Jamaica in 2011?
Offer a terse response. 5.79. What is the difference between the Expenses (% of total expenses) of Middle income in 2010 and the Expenses (% of total expenses) of Sierra Leone in 2011?
Your response must be concise. -1.77. What is the difference between the Expenses (% of total expenses) of Iceland in 2010 and the Expenses (% of total expenses) of Jamaica in 2011?
Your response must be concise. 11.99. What is the difference between the Expenses (% of total expenses) in Iceland in 2010 and the Expenses (% of total expenses) in Sierra Leone in 2011?
Offer a terse response. 4.42. What is the difference between the Expenses (% of total expenses) in Jamaica in 2010 and the Expenses (% of total expenses) in Sierra Leone in 2011?
Offer a very short reply. -8.89. What is the difference between the Expenses (% of total expenses) of Middle income in 2010 and the Expenses (% of total expenses) of Iceland in 2012?
Provide a short and direct response. -6.92. What is the difference between the Expenses (% of total expenses) of Middle income in 2010 and the Expenses (% of total expenses) of Jamaica in 2012?
Your answer should be very brief. 6.33. What is the difference between the Expenses (% of total expenses) in Middle income in 2010 and the Expenses (% of total expenses) in Sierra Leone in 2012?
Provide a succinct answer. -9.81. What is the difference between the Expenses (% of total expenses) in Iceland in 2010 and the Expenses (% of total expenses) in Jamaica in 2012?
Give a very brief answer. 12.52. What is the difference between the Expenses (% of total expenses) in Iceland in 2010 and the Expenses (% of total expenses) in Sierra Leone in 2012?
Offer a very short reply. -3.62. What is the difference between the Expenses (% of total expenses) in Jamaica in 2010 and the Expenses (% of total expenses) in Sierra Leone in 2012?
Keep it short and to the point. -16.93. What is the difference between the Expenses (% of total expenses) of Middle income in 2011 and the Expenses (% of total expenses) of Iceland in 2012?
Provide a short and direct response. -6.72. What is the difference between the Expenses (% of total expenses) in Middle income in 2011 and the Expenses (% of total expenses) in Jamaica in 2012?
Your response must be concise. 6.53. What is the difference between the Expenses (% of total expenses) of Middle income in 2011 and the Expenses (% of total expenses) of Sierra Leone in 2012?
Make the answer very short. -9.61. What is the difference between the Expenses (% of total expenses) in Iceland in 2011 and the Expenses (% of total expenses) in Jamaica in 2012?
Provide a short and direct response. 13.01. What is the difference between the Expenses (% of total expenses) of Iceland in 2011 and the Expenses (% of total expenses) of Sierra Leone in 2012?
Give a very brief answer. -3.13. What is the difference between the Expenses (% of total expenses) of Jamaica in 2011 and the Expenses (% of total expenses) of Sierra Leone in 2012?
Keep it short and to the point. -15.61. What is the average Expenses (% of total expenses) in Middle income per year?
Provide a short and direct response. 14.83. What is the average Expenses (% of total expenses) of Iceland per year?
Your answer should be compact. 21.8. What is the average Expenses (% of total expenses) of Jamaica per year?
Offer a terse response. 7.53. What is the average Expenses (% of total expenses) in Sierra Leone per year?
Provide a short and direct response. 22.05. In the year 2005, what is the difference between the Expenses (% of total expenses) in Middle income and Expenses (% of total expenses) in Iceland?
Offer a very short reply. -7.64. In the year 2005, what is the difference between the Expenses (% of total expenses) in Middle income and Expenses (% of total expenses) in Jamaica?
Offer a terse response. 8.12. In the year 2005, what is the difference between the Expenses (% of total expenses) of Middle income and Expenses (% of total expenses) of Sierra Leone?
Give a very brief answer. -9.1. In the year 2005, what is the difference between the Expenses (% of total expenses) of Iceland and Expenses (% of total expenses) of Jamaica?
Provide a succinct answer. 15.76. In the year 2005, what is the difference between the Expenses (% of total expenses) of Iceland and Expenses (% of total expenses) of Sierra Leone?
Provide a short and direct response. -1.46. In the year 2005, what is the difference between the Expenses (% of total expenses) of Jamaica and Expenses (% of total expenses) of Sierra Leone?
Ensure brevity in your answer.  -17.21. In the year 2006, what is the difference between the Expenses (% of total expenses) in Middle income and Expenses (% of total expenses) in Iceland?
Provide a succinct answer. -8.37. In the year 2006, what is the difference between the Expenses (% of total expenses) of Middle income and Expenses (% of total expenses) of Jamaica?
Your response must be concise. 8.52. In the year 2006, what is the difference between the Expenses (% of total expenses) of Middle income and Expenses (% of total expenses) of Sierra Leone?
Keep it short and to the point. -6.9. In the year 2006, what is the difference between the Expenses (% of total expenses) in Iceland and Expenses (% of total expenses) in Jamaica?
Offer a terse response. 16.89. In the year 2006, what is the difference between the Expenses (% of total expenses) of Iceland and Expenses (% of total expenses) of Sierra Leone?
Provide a succinct answer. 1.46. In the year 2006, what is the difference between the Expenses (% of total expenses) in Jamaica and Expenses (% of total expenses) in Sierra Leone?
Offer a very short reply. -15.43. In the year 2007, what is the difference between the Expenses (% of total expenses) in Middle income and Expenses (% of total expenses) in Iceland?
Ensure brevity in your answer.  -8.79. In the year 2007, what is the difference between the Expenses (% of total expenses) in Middle income and Expenses (% of total expenses) in Jamaica?
Offer a very short reply. 7.55. In the year 2007, what is the difference between the Expenses (% of total expenses) of Middle income and Expenses (% of total expenses) of Sierra Leone?
Give a very brief answer. -5.36. In the year 2007, what is the difference between the Expenses (% of total expenses) of Iceland and Expenses (% of total expenses) of Jamaica?
Give a very brief answer. 16.34. In the year 2007, what is the difference between the Expenses (% of total expenses) in Iceland and Expenses (% of total expenses) in Sierra Leone?
Offer a very short reply. 3.43. In the year 2007, what is the difference between the Expenses (% of total expenses) of Jamaica and Expenses (% of total expenses) of Sierra Leone?
Your answer should be very brief. -12.91. In the year 2008, what is the difference between the Expenses (% of total expenses) of Middle income and Expenses (% of total expenses) of Iceland?
Your response must be concise. -3.34. In the year 2008, what is the difference between the Expenses (% of total expenses) in Middle income and Expenses (% of total expenses) in Jamaica?
Keep it short and to the point. 6.15. In the year 2008, what is the difference between the Expenses (% of total expenses) in Middle income and Expenses (% of total expenses) in Sierra Leone?
Offer a terse response. -8.19. In the year 2008, what is the difference between the Expenses (% of total expenses) in Iceland and Expenses (% of total expenses) in Jamaica?
Keep it short and to the point. 9.49. In the year 2008, what is the difference between the Expenses (% of total expenses) of Iceland and Expenses (% of total expenses) of Sierra Leone?
Provide a succinct answer. -4.84. In the year 2008, what is the difference between the Expenses (% of total expenses) in Jamaica and Expenses (% of total expenses) in Sierra Leone?
Offer a very short reply. -14.33. In the year 2009, what is the difference between the Expenses (% of total expenses) of Middle income and Expenses (% of total expenses) of Iceland?
Your answer should be compact. -9.41. In the year 2009, what is the difference between the Expenses (% of total expenses) of Middle income and Expenses (% of total expenses) of Jamaica?
Your answer should be very brief. 7.29. In the year 2009, what is the difference between the Expenses (% of total expenses) of Middle income and Expenses (% of total expenses) of Sierra Leone?
Offer a terse response. -11.48. In the year 2009, what is the difference between the Expenses (% of total expenses) in Iceland and Expenses (% of total expenses) in Jamaica?
Provide a short and direct response. 16.7. In the year 2009, what is the difference between the Expenses (% of total expenses) in Iceland and Expenses (% of total expenses) in Sierra Leone?
Offer a very short reply. -2.07. In the year 2009, what is the difference between the Expenses (% of total expenses) of Jamaica and Expenses (% of total expenses) of Sierra Leone?
Offer a very short reply. -18.77. In the year 2010, what is the difference between the Expenses (% of total expenses) in Middle income and Expenses (% of total expenses) in Iceland?
Your answer should be very brief. -6.19. In the year 2010, what is the difference between the Expenses (% of total expenses) in Middle income and Expenses (% of total expenses) in Jamaica?
Offer a very short reply. 7.12. In the year 2010, what is the difference between the Expenses (% of total expenses) of Middle income and Expenses (% of total expenses) of Sierra Leone?
Give a very brief answer. -6.65. In the year 2010, what is the difference between the Expenses (% of total expenses) in Iceland and Expenses (% of total expenses) in Jamaica?
Ensure brevity in your answer.  13.31. In the year 2010, what is the difference between the Expenses (% of total expenses) in Iceland and Expenses (% of total expenses) in Sierra Leone?
Offer a very short reply. -0.46. In the year 2010, what is the difference between the Expenses (% of total expenses) of Jamaica and Expenses (% of total expenses) of Sierra Leone?
Provide a succinct answer. -13.77. In the year 2011, what is the difference between the Expenses (% of total expenses) of Middle income and Expenses (% of total expenses) of Iceland?
Provide a succinct answer. -6.48. In the year 2011, what is the difference between the Expenses (% of total expenses) of Middle income and Expenses (% of total expenses) of Jamaica?
Make the answer very short. 5.99. In the year 2011, what is the difference between the Expenses (% of total expenses) of Middle income and Expenses (% of total expenses) of Sierra Leone?
Your answer should be very brief. -1.57. In the year 2011, what is the difference between the Expenses (% of total expenses) of Iceland and Expenses (% of total expenses) of Jamaica?
Your answer should be compact. 12.47. In the year 2011, what is the difference between the Expenses (% of total expenses) in Iceland and Expenses (% of total expenses) in Sierra Leone?
Give a very brief answer. 4.91. In the year 2011, what is the difference between the Expenses (% of total expenses) of Jamaica and Expenses (% of total expenses) of Sierra Leone?
Provide a succinct answer. -7.57. In the year 2012, what is the difference between the Expenses (% of total expenses) in Middle income and Expenses (% of total expenses) in Iceland?
Ensure brevity in your answer.  -5.57. In the year 2012, what is the difference between the Expenses (% of total expenses) in Middle income and Expenses (% of total expenses) in Jamaica?
Provide a succinct answer. 7.68. In the year 2012, what is the difference between the Expenses (% of total expenses) in Middle income and Expenses (% of total expenses) in Sierra Leone?
Give a very brief answer. -8.46. In the year 2012, what is the difference between the Expenses (% of total expenses) of Iceland and Expenses (% of total expenses) of Jamaica?
Your response must be concise. 13.26. In the year 2012, what is the difference between the Expenses (% of total expenses) in Iceland and Expenses (% of total expenses) in Sierra Leone?
Give a very brief answer. -2.89. In the year 2012, what is the difference between the Expenses (% of total expenses) of Jamaica and Expenses (% of total expenses) of Sierra Leone?
Keep it short and to the point. -16.15. What is the ratio of the Expenses (% of total expenses) of Middle income in 2005 to that in 2006?
Offer a very short reply. 1.03. What is the ratio of the Expenses (% of total expenses) of Iceland in 2005 to that in 2006?
Offer a very short reply. 0.99. What is the ratio of the Expenses (% of total expenses) in Jamaica in 2005 to that in 2006?
Your response must be concise. 1.11. What is the ratio of the Expenses (% of total expenses) in Sierra Leone in 2005 to that in 2006?
Offer a very short reply. 1.11. What is the ratio of the Expenses (% of total expenses) of Middle income in 2005 to that in 2007?
Your answer should be very brief. 1.07. What is the ratio of the Expenses (% of total expenses) in Jamaica in 2005 to that in 2007?
Make the answer very short. 1.07. What is the ratio of the Expenses (% of total expenses) of Sierra Leone in 2005 to that in 2007?
Ensure brevity in your answer.  1.23. What is the ratio of the Expenses (% of total expenses) in Middle income in 2005 to that in 2008?
Your response must be concise. 1.19. What is the ratio of the Expenses (% of total expenses) in Iceland in 2005 to that in 2008?
Make the answer very short. 1.4. What is the ratio of the Expenses (% of total expenses) in Jamaica in 2005 to that in 2008?
Your answer should be compact. 1.08. What is the ratio of the Expenses (% of total expenses) of Sierra Leone in 2005 to that in 2008?
Offer a very short reply. 1.16. What is the ratio of the Expenses (% of total expenses) of Middle income in 2005 to that in 2009?
Make the answer very short. 1.29. What is the ratio of the Expenses (% of total expenses) of Iceland in 2005 to that in 2009?
Your answer should be compact. 1.09. What is the ratio of the Expenses (% of total expenses) of Jamaica in 2005 to that in 2009?
Keep it short and to the point. 1.52. What is the ratio of the Expenses (% of total expenses) of Sierra Leone in 2005 to that in 2009?
Your response must be concise. 1.05. What is the ratio of the Expenses (% of total expenses) in Middle income in 2005 to that in 2010?
Give a very brief answer. 1.16. What is the ratio of the Expenses (% of total expenses) in Iceland in 2005 to that in 2010?
Your response must be concise. 1.18. What is the ratio of the Expenses (% of total expenses) in Jamaica in 2005 to that in 2010?
Provide a short and direct response. 1.18. What is the ratio of the Expenses (% of total expenses) of Sierra Leone in 2005 to that in 2010?
Provide a succinct answer. 1.23. What is the ratio of the Expenses (% of total expenses) of Middle income in 2005 to that in 2011?
Your answer should be compact. 1.15. What is the ratio of the Expenses (% of total expenses) of Iceland in 2005 to that in 2011?
Give a very brief answer. 1.16. What is the ratio of the Expenses (% of total expenses) of Sierra Leone in 2005 to that in 2011?
Provide a short and direct response. 1.6. What is the ratio of the Expenses (% of total expenses) in Middle income in 2005 to that in 2012?
Provide a succinct answer. 1.06. What is the ratio of the Expenses (% of total expenses) of Iceland in 2005 to that in 2012?
Provide a succinct answer. 1.14. What is the ratio of the Expenses (% of total expenses) of Jamaica in 2005 to that in 2012?
Your answer should be very brief. 1.06. What is the ratio of the Expenses (% of total expenses) in Sierra Leone in 2005 to that in 2012?
Your answer should be compact. 1.07. What is the ratio of the Expenses (% of total expenses) of Middle income in 2006 to that in 2007?
Your answer should be very brief. 1.05. What is the ratio of the Expenses (% of total expenses) in Iceland in 2006 to that in 2007?
Make the answer very short. 1.01. What is the ratio of the Expenses (% of total expenses) of Jamaica in 2006 to that in 2007?
Your response must be concise. 0.96. What is the ratio of the Expenses (% of total expenses) of Sierra Leone in 2006 to that in 2007?
Ensure brevity in your answer.  1.11. What is the ratio of the Expenses (% of total expenses) of Middle income in 2006 to that in 2008?
Your answer should be compact. 1.16. What is the ratio of the Expenses (% of total expenses) of Iceland in 2006 to that in 2008?
Provide a succinct answer. 1.42. What is the ratio of the Expenses (% of total expenses) in Jamaica in 2006 to that in 2008?
Provide a short and direct response. 0.98. What is the ratio of the Expenses (% of total expenses) of Sierra Leone in 2006 to that in 2008?
Provide a short and direct response. 1.04. What is the ratio of the Expenses (% of total expenses) of Middle income in 2006 to that in 2009?
Your answer should be very brief. 1.26. What is the ratio of the Expenses (% of total expenses) of Iceland in 2006 to that in 2009?
Make the answer very short. 1.1. What is the ratio of the Expenses (% of total expenses) in Jamaica in 2006 to that in 2009?
Your answer should be very brief. 1.38. What is the ratio of the Expenses (% of total expenses) of Sierra Leone in 2006 to that in 2009?
Make the answer very short. 0.95. What is the ratio of the Expenses (% of total expenses) in Middle income in 2006 to that in 2010?
Offer a terse response. 1.13. What is the ratio of the Expenses (% of total expenses) of Iceland in 2006 to that in 2010?
Provide a short and direct response. 1.2. What is the ratio of the Expenses (% of total expenses) in Jamaica in 2006 to that in 2010?
Offer a terse response. 1.07. What is the ratio of the Expenses (% of total expenses) of Sierra Leone in 2006 to that in 2010?
Provide a short and direct response. 1.1. What is the ratio of the Expenses (% of total expenses) of Middle income in 2006 to that in 2011?
Your answer should be compact. 1.12. What is the ratio of the Expenses (% of total expenses) in Iceland in 2006 to that in 2011?
Provide a succinct answer. 1.17. What is the ratio of the Expenses (% of total expenses) in Jamaica in 2006 to that in 2011?
Your response must be concise. 0.9. What is the ratio of the Expenses (% of total expenses) of Sierra Leone in 2006 to that in 2011?
Your answer should be very brief. 1.44. What is the ratio of the Expenses (% of total expenses) in Middle income in 2006 to that in 2012?
Give a very brief answer. 1.03. What is the ratio of the Expenses (% of total expenses) in Iceland in 2006 to that in 2012?
Ensure brevity in your answer.  1.16. What is the ratio of the Expenses (% of total expenses) of Jamaica in 2006 to that in 2012?
Provide a succinct answer. 0.96. What is the ratio of the Expenses (% of total expenses) of Sierra Leone in 2006 to that in 2012?
Provide a short and direct response. 0.96. What is the ratio of the Expenses (% of total expenses) of Middle income in 2007 to that in 2008?
Make the answer very short. 1.11. What is the ratio of the Expenses (% of total expenses) of Iceland in 2007 to that in 2008?
Your answer should be compact. 1.4. What is the ratio of the Expenses (% of total expenses) in Jamaica in 2007 to that in 2008?
Keep it short and to the point. 1.01. What is the ratio of the Expenses (% of total expenses) in Sierra Leone in 2007 to that in 2008?
Keep it short and to the point. 0.94. What is the ratio of the Expenses (% of total expenses) of Middle income in 2007 to that in 2009?
Ensure brevity in your answer.  1.2. What is the ratio of the Expenses (% of total expenses) of Iceland in 2007 to that in 2009?
Provide a succinct answer. 1.09. What is the ratio of the Expenses (% of total expenses) of Jamaica in 2007 to that in 2009?
Provide a short and direct response. 1.43. What is the ratio of the Expenses (% of total expenses) in Sierra Leone in 2007 to that in 2009?
Offer a very short reply. 0.85. What is the ratio of the Expenses (% of total expenses) of Middle income in 2007 to that in 2010?
Ensure brevity in your answer.  1.08. What is the ratio of the Expenses (% of total expenses) of Iceland in 2007 to that in 2010?
Make the answer very short. 1.19. What is the ratio of the Expenses (% of total expenses) in Jamaica in 2007 to that in 2010?
Your answer should be compact. 1.11. What is the ratio of the Expenses (% of total expenses) in Sierra Leone in 2007 to that in 2010?
Offer a terse response. 0.99. What is the ratio of the Expenses (% of total expenses) in Middle income in 2007 to that in 2011?
Provide a succinct answer. 1.07. What is the ratio of the Expenses (% of total expenses) of Iceland in 2007 to that in 2011?
Provide a short and direct response. 1.16. What is the ratio of the Expenses (% of total expenses) in Jamaica in 2007 to that in 2011?
Offer a very short reply. 0.93. What is the ratio of the Expenses (% of total expenses) in Sierra Leone in 2007 to that in 2011?
Offer a terse response. 1.3. What is the ratio of the Expenses (% of total expenses) in Middle income in 2007 to that in 2012?
Offer a very short reply. 0.99. What is the ratio of the Expenses (% of total expenses) in Iceland in 2007 to that in 2012?
Give a very brief answer. 1.14. What is the ratio of the Expenses (% of total expenses) of Jamaica in 2007 to that in 2012?
Your response must be concise. 1. What is the ratio of the Expenses (% of total expenses) in Sierra Leone in 2007 to that in 2012?
Ensure brevity in your answer.  0.86. What is the ratio of the Expenses (% of total expenses) of Middle income in 2008 to that in 2009?
Ensure brevity in your answer.  1.09. What is the ratio of the Expenses (% of total expenses) of Iceland in 2008 to that in 2009?
Give a very brief answer. 0.78. What is the ratio of the Expenses (% of total expenses) of Jamaica in 2008 to that in 2009?
Give a very brief answer. 1.41. What is the ratio of the Expenses (% of total expenses) in Sierra Leone in 2008 to that in 2009?
Your response must be concise. 0.91. What is the ratio of the Expenses (% of total expenses) of Middle income in 2008 to that in 2010?
Provide a succinct answer. 0.98. What is the ratio of the Expenses (% of total expenses) of Iceland in 2008 to that in 2010?
Your response must be concise. 0.84. What is the ratio of the Expenses (% of total expenses) in Jamaica in 2008 to that in 2010?
Provide a short and direct response. 1.09. What is the ratio of the Expenses (% of total expenses) of Sierra Leone in 2008 to that in 2010?
Provide a short and direct response. 1.06. What is the ratio of the Expenses (% of total expenses) of Middle income in 2008 to that in 2011?
Provide a short and direct response. 0.96. What is the ratio of the Expenses (% of total expenses) in Iceland in 2008 to that in 2011?
Ensure brevity in your answer.  0.83. What is the ratio of the Expenses (% of total expenses) of Jamaica in 2008 to that in 2011?
Give a very brief answer. 0.92. What is the ratio of the Expenses (% of total expenses) in Sierra Leone in 2008 to that in 2011?
Provide a succinct answer. 1.38. What is the ratio of the Expenses (% of total expenses) in Middle income in 2008 to that in 2012?
Make the answer very short. 0.89. What is the ratio of the Expenses (% of total expenses) of Iceland in 2008 to that in 2012?
Your answer should be very brief. 0.82. What is the ratio of the Expenses (% of total expenses) in Jamaica in 2008 to that in 2012?
Give a very brief answer. 0.98. What is the ratio of the Expenses (% of total expenses) in Sierra Leone in 2008 to that in 2012?
Offer a terse response. 0.92. What is the ratio of the Expenses (% of total expenses) in Middle income in 2009 to that in 2010?
Ensure brevity in your answer.  0.9. What is the ratio of the Expenses (% of total expenses) in Iceland in 2009 to that in 2010?
Keep it short and to the point. 1.09. What is the ratio of the Expenses (% of total expenses) in Jamaica in 2009 to that in 2010?
Keep it short and to the point. 0.78. What is the ratio of the Expenses (% of total expenses) in Sierra Leone in 2009 to that in 2010?
Offer a very short reply. 1.16. What is the ratio of the Expenses (% of total expenses) in Middle income in 2009 to that in 2011?
Provide a succinct answer. 0.89. What is the ratio of the Expenses (% of total expenses) of Iceland in 2009 to that in 2011?
Make the answer very short. 1.06. What is the ratio of the Expenses (% of total expenses) of Jamaica in 2009 to that in 2011?
Provide a succinct answer. 0.65. What is the ratio of the Expenses (% of total expenses) in Sierra Leone in 2009 to that in 2011?
Keep it short and to the point. 1.52. What is the ratio of the Expenses (% of total expenses) of Middle income in 2009 to that in 2012?
Give a very brief answer. 0.82. What is the ratio of the Expenses (% of total expenses) in Iceland in 2009 to that in 2012?
Make the answer very short. 1.05. What is the ratio of the Expenses (% of total expenses) of Jamaica in 2009 to that in 2012?
Give a very brief answer. 0.7. What is the ratio of the Expenses (% of total expenses) of Sierra Leone in 2009 to that in 2012?
Keep it short and to the point. 1.01. What is the ratio of the Expenses (% of total expenses) of Middle income in 2010 to that in 2011?
Provide a short and direct response. 0.99. What is the ratio of the Expenses (% of total expenses) of Iceland in 2010 to that in 2011?
Keep it short and to the point. 0.98. What is the ratio of the Expenses (% of total expenses) of Jamaica in 2010 to that in 2011?
Offer a very short reply. 0.84. What is the ratio of the Expenses (% of total expenses) in Sierra Leone in 2010 to that in 2011?
Give a very brief answer. 1.31. What is the ratio of the Expenses (% of total expenses) in Middle income in 2010 to that in 2012?
Your response must be concise. 0.91. What is the ratio of the Expenses (% of total expenses) of Iceland in 2010 to that in 2012?
Ensure brevity in your answer.  0.97. What is the ratio of the Expenses (% of total expenses) in Jamaica in 2010 to that in 2012?
Offer a terse response. 0.9. What is the ratio of the Expenses (% of total expenses) of Sierra Leone in 2010 to that in 2012?
Make the answer very short. 0.87. What is the ratio of the Expenses (% of total expenses) of Middle income in 2011 to that in 2012?
Provide a short and direct response. 0.93. What is the ratio of the Expenses (% of total expenses) of Jamaica in 2011 to that in 2012?
Provide a short and direct response. 1.07. What is the ratio of the Expenses (% of total expenses) in Sierra Leone in 2011 to that in 2012?
Offer a terse response. 0.66. What is the difference between the highest and the second highest Expenses (% of total expenses) of Middle income?
Offer a very short reply. 0.41. What is the difference between the highest and the second highest Expenses (% of total expenses) in Iceland?
Keep it short and to the point. 0.27. What is the difference between the highest and the second highest Expenses (% of total expenses) in Jamaica?
Keep it short and to the point. 0.03. What is the difference between the highest and the second highest Expenses (% of total expenses) of Sierra Leone?
Your response must be concise. 1.32. What is the difference between the highest and the lowest Expenses (% of total expenses) in Middle income?
Keep it short and to the point. 3.7. What is the difference between the highest and the lowest Expenses (% of total expenses) of Iceland?
Give a very brief answer. 7.22. What is the difference between the highest and the lowest Expenses (% of total expenses) of Jamaica?
Provide a succinct answer. 2.91. What is the difference between the highest and the lowest Expenses (% of total expenses) of Sierra Leone?
Your answer should be compact. 9.62. 